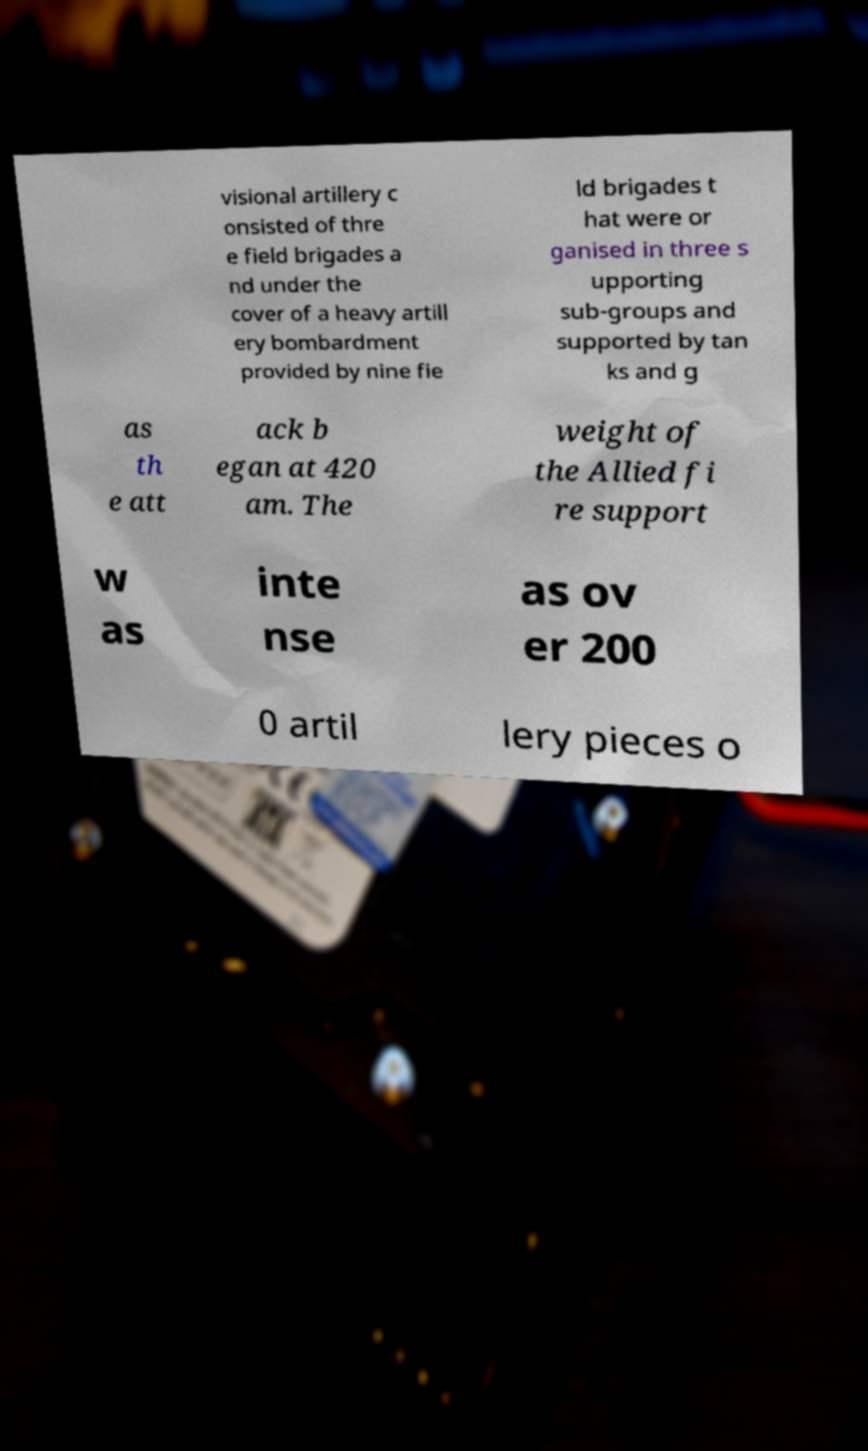For documentation purposes, I need the text within this image transcribed. Could you provide that? visional artillery c onsisted of thre e field brigades a nd under the cover of a heavy artill ery bombardment provided by nine fie ld brigades t hat were or ganised in three s upporting sub-groups and supported by tan ks and g as th e att ack b egan at 420 am. The weight of the Allied fi re support w as inte nse as ov er 200 0 artil lery pieces o 